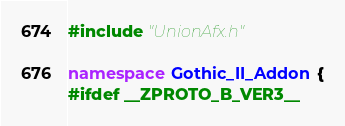Convert code to text. <code><loc_0><loc_0><loc_500><loc_500><_C++_>#include "UnionAfx.h"

namespace Gothic_II_Addon {
#ifdef __ZPROTO_B_VER3__</code> 